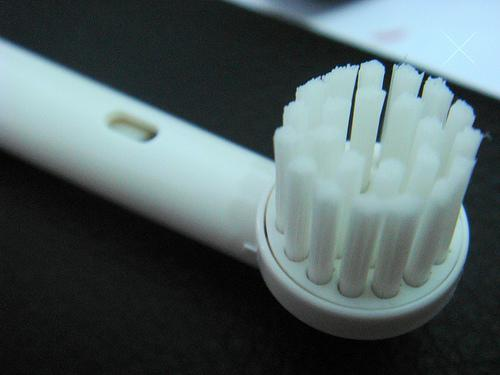Question: what is this?
Choices:
A. A pencil.
B. A toothbrush.
C. A pen.
D. A brush.
Answer with the letter. Answer: B Question: why are the bristles soft?
Choices:
A. For delicate work.
B. For painting.
C. For soft scrubbing.
D. For the teeth.
Answer with the letter. Answer: D Question: who can be seen?
Choices:
A. One person.
B. Two people.
C. No one.
D. Three people.
Answer with the letter. Answer: C Question: how many toothbrushes can be seen?
Choices:
A. 2.
B. 3.
C. 4.
D. 1.
Answer with the letter. Answer: D 